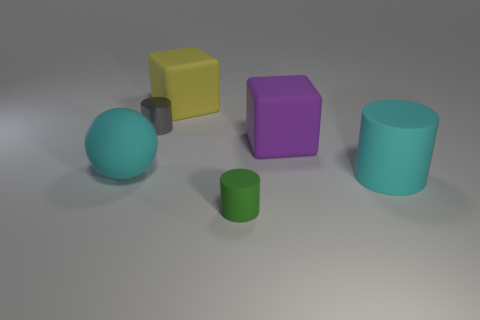Subtract all cyan rubber cylinders. How many cylinders are left? 2 Add 1 tiny red balls. How many objects exist? 7 Subtract all gray cylinders. How many cylinders are left? 2 Subtract 1 blocks. How many blocks are left? 1 Subtract all gray spheres. Subtract all cyan cylinders. How many spheres are left? 1 Subtract all brown cubes. How many green cylinders are left? 1 Subtract all blocks. How many objects are left? 4 Subtract all big purple blocks. Subtract all big rubber cylinders. How many objects are left? 4 Add 4 big cylinders. How many big cylinders are left? 5 Add 1 spheres. How many spheres exist? 2 